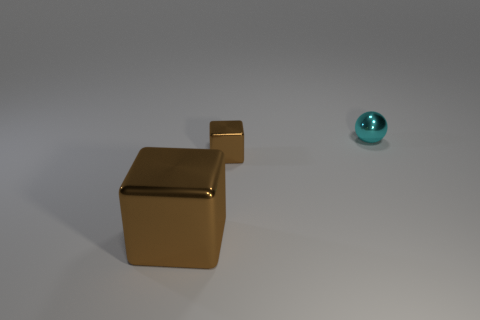Can you describe the lighting setup used in this scene? The image seems to be lit with a soft, overall lighting setup, that provides a gentle shadow under the objects, indicating a diffuse light source. The shadows are soft-edged which means the light source is not too harsh, creating a calm and evenly lit scene. 